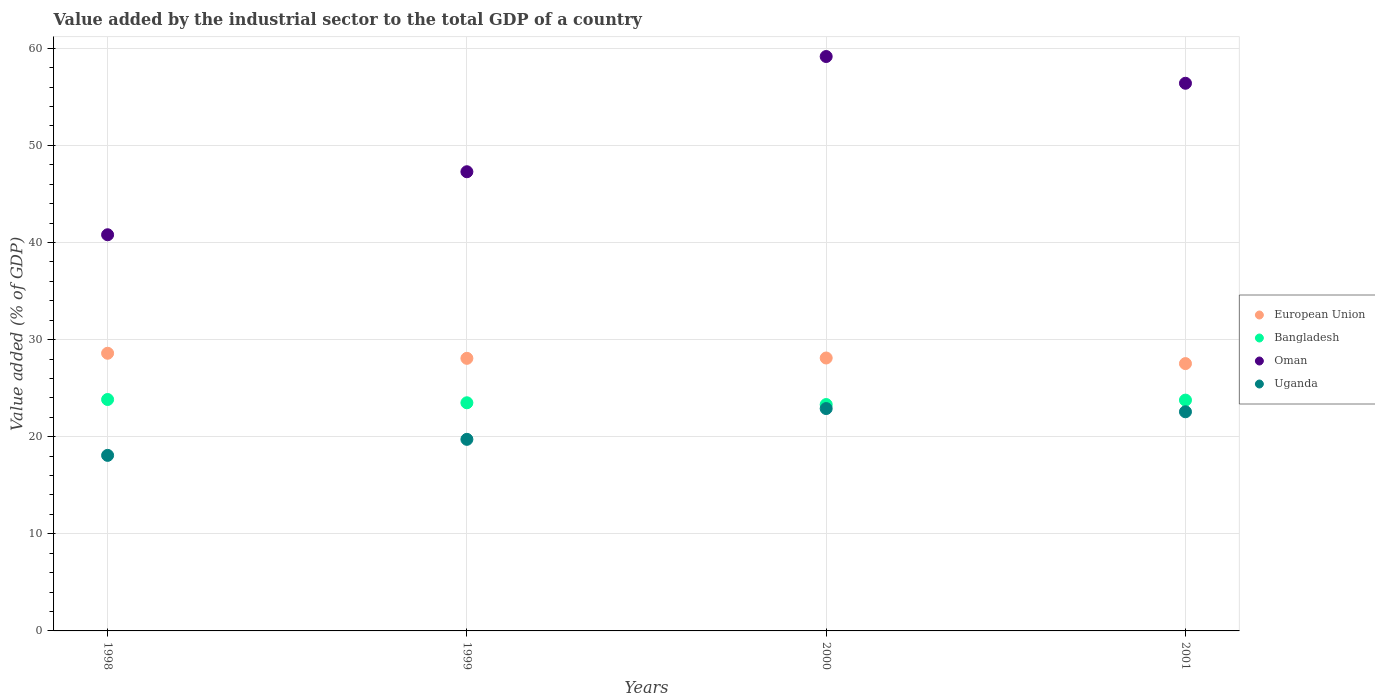How many different coloured dotlines are there?
Your response must be concise. 4. What is the value added by the industrial sector to the total GDP in Uganda in 1998?
Your answer should be compact. 18.08. Across all years, what is the maximum value added by the industrial sector to the total GDP in European Union?
Offer a terse response. 28.6. Across all years, what is the minimum value added by the industrial sector to the total GDP in European Union?
Provide a short and direct response. 27.53. What is the total value added by the industrial sector to the total GDP in European Union in the graph?
Provide a succinct answer. 112.31. What is the difference between the value added by the industrial sector to the total GDP in Uganda in 1998 and that in 2001?
Your answer should be compact. -4.49. What is the difference between the value added by the industrial sector to the total GDP in Bangladesh in 1999 and the value added by the industrial sector to the total GDP in Oman in 2001?
Offer a very short reply. -32.91. What is the average value added by the industrial sector to the total GDP in Bangladesh per year?
Your answer should be compact. 23.6. In the year 1998, what is the difference between the value added by the industrial sector to the total GDP in Bangladesh and value added by the industrial sector to the total GDP in European Union?
Your response must be concise. -4.76. In how many years, is the value added by the industrial sector to the total GDP in Oman greater than 22 %?
Your answer should be compact. 4. What is the ratio of the value added by the industrial sector to the total GDP in European Union in 1998 to that in 2001?
Your response must be concise. 1.04. What is the difference between the highest and the second highest value added by the industrial sector to the total GDP in Uganda?
Provide a succinct answer. 0.33. What is the difference between the highest and the lowest value added by the industrial sector to the total GDP in Oman?
Your answer should be compact. 18.36. In how many years, is the value added by the industrial sector to the total GDP in Uganda greater than the average value added by the industrial sector to the total GDP in Uganda taken over all years?
Keep it short and to the point. 2. Is it the case that in every year, the sum of the value added by the industrial sector to the total GDP in Uganda and value added by the industrial sector to the total GDP in Bangladesh  is greater than the value added by the industrial sector to the total GDP in European Union?
Offer a terse response. Yes. Is the value added by the industrial sector to the total GDP in Oman strictly greater than the value added by the industrial sector to the total GDP in European Union over the years?
Your answer should be compact. Yes. Is the value added by the industrial sector to the total GDP in European Union strictly less than the value added by the industrial sector to the total GDP in Bangladesh over the years?
Give a very brief answer. No. How many dotlines are there?
Offer a terse response. 4. Are the values on the major ticks of Y-axis written in scientific E-notation?
Make the answer very short. No. Does the graph contain any zero values?
Provide a succinct answer. No. What is the title of the graph?
Give a very brief answer. Value added by the industrial sector to the total GDP of a country. What is the label or title of the X-axis?
Give a very brief answer. Years. What is the label or title of the Y-axis?
Your answer should be very brief. Value added (% of GDP). What is the Value added (% of GDP) in European Union in 1998?
Ensure brevity in your answer.  28.6. What is the Value added (% of GDP) of Bangladesh in 1998?
Ensure brevity in your answer.  23.83. What is the Value added (% of GDP) of Oman in 1998?
Offer a very short reply. 40.8. What is the Value added (% of GDP) of Uganda in 1998?
Offer a terse response. 18.08. What is the Value added (% of GDP) in European Union in 1999?
Provide a succinct answer. 28.07. What is the Value added (% of GDP) in Bangladesh in 1999?
Your answer should be very brief. 23.5. What is the Value added (% of GDP) of Oman in 1999?
Keep it short and to the point. 47.29. What is the Value added (% of GDP) of Uganda in 1999?
Your answer should be very brief. 19.73. What is the Value added (% of GDP) in European Union in 2000?
Make the answer very short. 28.11. What is the Value added (% of GDP) of Bangladesh in 2000?
Keep it short and to the point. 23.31. What is the Value added (% of GDP) of Oman in 2000?
Offer a very short reply. 59.16. What is the Value added (% of GDP) in Uganda in 2000?
Keep it short and to the point. 22.9. What is the Value added (% of GDP) in European Union in 2001?
Ensure brevity in your answer.  27.53. What is the Value added (% of GDP) of Bangladesh in 2001?
Provide a succinct answer. 23.77. What is the Value added (% of GDP) in Oman in 2001?
Keep it short and to the point. 56.4. What is the Value added (% of GDP) of Uganda in 2001?
Make the answer very short. 22.57. Across all years, what is the maximum Value added (% of GDP) of European Union?
Provide a succinct answer. 28.6. Across all years, what is the maximum Value added (% of GDP) in Bangladesh?
Make the answer very short. 23.83. Across all years, what is the maximum Value added (% of GDP) of Oman?
Keep it short and to the point. 59.16. Across all years, what is the maximum Value added (% of GDP) in Uganda?
Make the answer very short. 22.9. Across all years, what is the minimum Value added (% of GDP) of European Union?
Your answer should be compact. 27.53. Across all years, what is the minimum Value added (% of GDP) of Bangladesh?
Make the answer very short. 23.31. Across all years, what is the minimum Value added (% of GDP) in Oman?
Give a very brief answer. 40.8. Across all years, what is the minimum Value added (% of GDP) in Uganda?
Offer a terse response. 18.08. What is the total Value added (% of GDP) of European Union in the graph?
Give a very brief answer. 112.31. What is the total Value added (% of GDP) in Bangladesh in the graph?
Keep it short and to the point. 94.41. What is the total Value added (% of GDP) of Oman in the graph?
Keep it short and to the point. 203.64. What is the total Value added (% of GDP) in Uganda in the graph?
Offer a terse response. 83.28. What is the difference between the Value added (% of GDP) in European Union in 1998 and that in 1999?
Keep it short and to the point. 0.52. What is the difference between the Value added (% of GDP) of Bangladesh in 1998 and that in 1999?
Provide a short and direct response. 0.34. What is the difference between the Value added (% of GDP) in Oman in 1998 and that in 1999?
Make the answer very short. -6.49. What is the difference between the Value added (% of GDP) of Uganda in 1998 and that in 1999?
Keep it short and to the point. -1.65. What is the difference between the Value added (% of GDP) of European Union in 1998 and that in 2000?
Offer a terse response. 0.49. What is the difference between the Value added (% of GDP) of Bangladesh in 1998 and that in 2000?
Give a very brief answer. 0.52. What is the difference between the Value added (% of GDP) of Oman in 1998 and that in 2000?
Your response must be concise. -18.36. What is the difference between the Value added (% of GDP) in Uganda in 1998 and that in 2000?
Offer a very short reply. -4.82. What is the difference between the Value added (% of GDP) in European Union in 1998 and that in 2001?
Your answer should be very brief. 1.06. What is the difference between the Value added (% of GDP) of Bangladesh in 1998 and that in 2001?
Your answer should be compact. 0.06. What is the difference between the Value added (% of GDP) of Oman in 1998 and that in 2001?
Your response must be concise. -15.6. What is the difference between the Value added (% of GDP) of Uganda in 1998 and that in 2001?
Your answer should be compact. -4.49. What is the difference between the Value added (% of GDP) of European Union in 1999 and that in 2000?
Offer a terse response. -0.03. What is the difference between the Value added (% of GDP) in Bangladesh in 1999 and that in 2000?
Make the answer very short. 0.18. What is the difference between the Value added (% of GDP) in Oman in 1999 and that in 2000?
Offer a terse response. -11.87. What is the difference between the Value added (% of GDP) of Uganda in 1999 and that in 2000?
Your answer should be compact. -3.17. What is the difference between the Value added (% of GDP) in European Union in 1999 and that in 2001?
Ensure brevity in your answer.  0.54. What is the difference between the Value added (% of GDP) in Bangladesh in 1999 and that in 2001?
Keep it short and to the point. -0.27. What is the difference between the Value added (% of GDP) of Oman in 1999 and that in 2001?
Your response must be concise. -9.11. What is the difference between the Value added (% of GDP) of Uganda in 1999 and that in 2001?
Your answer should be compact. -2.84. What is the difference between the Value added (% of GDP) in European Union in 2000 and that in 2001?
Keep it short and to the point. 0.58. What is the difference between the Value added (% of GDP) in Bangladesh in 2000 and that in 2001?
Ensure brevity in your answer.  -0.46. What is the difference between the Value added (% of GDP) of Oman in 2000 and that in 2001?
Offer a terse response. 2.75. What is the difference between the Value added (% of GDP) of Uganda in 2000 and that in 2001?
Give a very brief answer. 0.33. What is the difference between the Value added (% of GDP) in European Union in 1998 and the Value added (% of GDP) in Oman in 1999?
Provide a succinct answer. -18.69. What is the difference between the Value added (% of GDP) of European Union in 1998 and the Value added (% of GDP) of Uganda in 1999?
Provide a short and direct response. 8.87. What is the difference between the Value added (% of GDP) of Bangladesh in 1998 and the Value added (% of GDP) of Oman in 1999?
Ensure brevity in your answer.  -23.46. What is the difference between the Value added (% of GDP) of Bangladesh in 1998 and the Value added (% of GDP) of Uganda in 1999?
Keep it short and to the point. 4.1. What is the difference between the Value added (% of GDP) in Oman in 1998 and the Value added (% of GDP) in Uganda in 1999?
Ensure brevity in your answer.  21.07. What is the difference between the Value added (% of GDP) of European Union in 1998 and the Value added (% of GDP) of Bangladesh in 2000?
Your answer should be compact. 5.28. What is the difference between the Value added (% of GDP) of European Union in 1998 and the Value added (% of GDP) of Oman in 2000?
Your response must be concise. -30.56. What is the difference between the Value added (% of GDP) in European Union in 1998 and the Value added (% of GDP) in Uganda in 2000?
Your response must be concise. 5.7. What is the difference between the Value added (% of GDP) in Bangladesh in 1998 and the Value added (% of GDP) in Oman in 2000?
Your response must be concise. -35.32. What is the difference between the Value added (% of GDP) of Bangladesh in 1998 and the Value added (% of GDP) of Uganda in 2000?
Give a very brief answer. 0.93. What is the difference between the Value added (% of GDP) of Oman in 1998 and the Value added (% of GDP) of Uganda in 2000?
Offer a very short reply. 17.9. What is the difference between the Value added (% of GDP) in European Union in 1998 and the Value added (% of GDP) in Bangladesh in 2001?
Give a very brief answer. 4.83. What is the difference between the Value added (% of GDP) in European Union in 1998 and the Value added (% of GDP) in Oman in 2001?
Your answer should be very brief. -27.81. What is the difference between the Value added (% of GDP) of European Union in 1998 and the Value added (% of GDP) of Uganda in 2001?
Make the answer very short. 6.03. What is the difference between the Value added (% of GDP) of Bangladesh in 1998 and the Value added (% of GDP) of Oman in 2001?
Make the answer very short. -32.57. What is the difference between the Value added (% of GDP) of Bangladesh in 1998 and the Value added (% of GDP) of Uganda in 2001?
Provide a short and direct response. 1.26. What is the difference between the Value added (% of GDP) in Oman in 1998 and the Value added (% of GDP) in Uganda in 2001?
Make the answer very short. 18.23. What is the difference between the Value added (% of GDP) of European Union in 1999 and the Value added (% of GDP) of Bangladesh in 2000?
Offer a very short reply. 4.76. What is the difference between the Value added (% of GDP) in European Union in 1999 and the Value added (% of GDP) in Oman in 2000?
Keep it short and to the point. -31.08. What is the difference between the Value added (% of GDP) of European Union in 1999 and the Value added (% of GDP) of Uganda in 2000?
Your answer should be compact. 5.17. What is the difference between the Value added (% of GDP) in Bangladesh in 1999 and the Value added (% of GDP) in Oman in 2000?
Make the answer very short. -35.66. What is the difference between the Value added (% of GDP) of Bangladesh in 1999 and the Value added (% of GDP) of Uganda in 2000?
Your response must be concise. 0.6. What is the difference between the Value added (% of GDP) in Oman in 1999 and the Value added (% of GDP) in Uganda in 2000?
Your answer should be very brief. 24.39. What is the difference between the Value added (% of GDP) of European Union in 1999 and the Value added (% of GDP) of Bangladesh in 2001?
Your response must be concise. 4.3. What is the difference between the Value added (% of GDP) in European Union in 1999 and the Value added (% of GDP) in Oman in 2001?
Provide a short and direct response. -28.33. What is the difference between the Value added (% of GDP) of European Union in 1999 and the Value added (% of GDP) of Uganda in 2001?
Your answer should be compact. 5.5. What is the difference between the Value added (% of GDP) of Bangladesh in 1999 and the Value added (% of GDP) of Oman in 2001?
Provide a succinct answer. -32.91. What is the difference between the Value added (% of GDP) of Bangladesh in 1999 and the Value added (% of GDP) of Uganda in 2001?
Give a very brief answer. 0.93. What is the difference between the Value added (% of GDP) of Oman in 1999 and the Value added (% of GDP) of Uganda in 2001?
Your answer should be compact. 24.72. What is the difference between the Value added (% of GDP) of European Union in 2000 and the Value added (% of GDP) of Bangladesh in 2001?
Offer a very short reply. 4.34. What is the difference between the Value added (% of GDP) of European Union in 2000 and the Value added (% of GDP) of Oman in 2001?
Provide a succinct answer. -28.29. What is the difference between the Value added (% of GDP) of European Union in 2000 and the Value added (% of GDP) of Uganda in 2001?
Ensure brevity in your answer.  5.54. What is the difference between the Value added (% of GDP) of Bangladesh in 2000 and the Value added (% of GDP) of Oman in 2001?
Your response must be concise. -33.09. What is the difference between the Value added (% of GDP) in Bangladesh in 2000 and the Value added (% of GDP) in Uganda in 2001?
Your answer should be compact. 0.75. What is the difference between the Value added (% of GDP) in Oman in 2000 and the Value added (% of GDP) in Uganda in 2001?
Provide a short and direct response. 36.59. What is the average Value added (% of GDP) of European Union per year?
Provide a succinct answer. 28.08. What is the average Value added (% of GDP) in Bangladesh per year?
Your response must be concise. 23.6. What is the average Value added (% of GDP) of Oman per year?
Provide a succinct answer. 50.91. What is the average Value added (% of GDP) in Uganda per year?
Ensure brevity in your answer.  20.82. In the year 1998, what is the difference between the Value added (% of GDP) in European Union and Value added (% of GDP) in Bangladesh?
Give a very brief answer. 4.76. In the year 1998, what is the difference between the Value added (% of GDP) in European Union and Value added (% of GDP) in Oman?
Provide a succinct answer. -12.2. In the year 1998, what is the difference between the Value added (% of GDP) in European Union and Value added (% of GDP) in Uganda?
Make the answer very short. 10.52. In the year 1998, what is the difference between the Value added (% of GDP) of Bangladesh and Value added (% of GDP) of Oman?
Offer a very short reply. -16.97. In the year 1998, what is the difference between the Value added (% of GDP) in Bangladesh and Value added (% of GDP) in Uganda?
Your answer should be very brief. 5.75. In the year 1998, what is the difference between the Value added (% of GDP) in Oman and Value added (% of GDP) in Uganda?
Your answer should be compact. 22.72. In the year 1999, what is the difference between the Value added (% of GDP) of European Union and Value added (% of GDP) of Bangladesh?
Your response must be concise. 4.58. In the year 1999, what is the difference between the Value added (% of GDP) in European Union and Value added (% of GDP) in Oman?
Make the answer very short. -19.22. In the year 1999, what is the difference between the Value added (% of GDP) in European Union and Value added (% of GDP) in Uganda?
Make the answer very short. 8.34. In the year 1999, what is the difference between the Value added (% of GDP) in Bangladesh and Value added (% of GDP) in Oman?
Ensure brevity in your answer.  -23.79. In the year 1999, what is the difference between the Value added (% of GDP) in Bangladesh and Value added (% of GDP) in Uganda?
Your response must be concise. 3.77. In the year 1999, what is the difference between the Value added (% of GDP) in Oman and Value added (% of GDP) in Uganda?
Ensure brevity in your answer.  27.56. In the year 2000, what is the difference between the Value added (% of GDP) of European Union and Value added (% of GDP) of Bangladesh?
Your answer should be compact. 4.79. In the year 2000, what is the difference between the Value added (% of GDP) of European Union and Value added (% of GDP) of Oman?
Your answer should be compact. -31.05. In the year 2000, what is the difference between the Value added (% of GDP) in European Union and Value added (% of GDP) in Uganda?
Your answer should be compact. 5.21. In the year 2000, what is the difference between the Value added (% of GDP) in Bangladesh and Value added (% of GDP) in Oman?
Provide a short and direct response. -35.84. In the year 2000, what is the difference between the Value added (% of GDP) in Bangladesh and Value added (% of GDP) in Uganda?
Give a very brief answer. 0.41. In the year 2000, what is the difference between the Value added (% of GDP) of Oman and Value added (% of GDP) of Uganda?
Provide a short and direct response. 36.26. In the year 2001, what is the difference between the Value added (% of GDP) of European Union and Value added (% of GDP) of Bangladesh?
Provide a short and direct response. 3.76. In the year 2001, what is the difference between the Value added (% of GDP) of European Union and Value added (% of GDP) of Oman?
Provide a short and direct response. -28.87. In the year 2001, what is the difference between the Value added (% of GDP) of European Union and Value added (% of GDP) of Uganda?
Offer a very short reply. 4.96. In the year 2001, what is the difference between the Value added (% of GDP) in Bangladesh and Value added (% of GDP) in Oman?
Your response must be concise. -32.63. In the year 2001, what is the difference between the Value added (% of GDP) of Bangladesh and Value added (% of GDP) of Uganda?
Your answer should be very brief. 1.2. In the year 2001, what is the difference between the Value added (% of GDP) in Oman and Value added (% of GDP) in Uganda?
Your response must be concise. 33.83. What is the ratio of the Value added (% of GDP) of European Union in 1998 to that in 1999?
Your response must be concise. 1.02. What is the ratio of the Value added (% of GDP) of Bangladesh in 1998 to that in 1999?
Ensure brevity in your answer.  1.01. What is the ratio of the Value added (% of GDP) in Oman in 1998 to that in 1999?
Your answer should be very brief. 0.86. What is the ratio of the Value added (% of GDP) of Uganda in 1998 to that in 1999?
Your answer should be very brief. 0.92. What is the ratio of the Value added (% of GDP) of European Union in 1998 to that in 2000?
Your answer should be very brief. 1.02. What is the ratio of the Value added (% of GDP) of Bangladesh in 1998 to that in 2000?
Your response must be concise. 1.02. What is the ratio of the Value added (% of GDP) in Oman in 1998 to that in 2000?
Make the answer very short. 0.69. What is the ratio of the Value added (% of GDP) of Uganda in 1998 to that in 2000?
Offer a terse response. 0.79. What is the ratio of the Value added (% of GDP) of European Union in 1998 to that in 2001?
Offer a terse response. 1.04. What is the ratio of the Value added (% of GDP) of Oman in 1998 to that in 2001?
Your answer should be very brief. 0.72. What is the ratio of the Value added (% of GDP) in Uganda in 1998 to that in 2001?
Offer a terse response. 0.8. What is the ratio of the Value added (% of GDP) in Bangladesh in 1999 to that in 2000?
Provide a succinct answer. 1.01. What is the ratio of the Value added (% of GDP) in Oman in 1999 to that in 2000?
Your answer should be very brief. 0.8. What is the ratio of the Value added (% of GDP) of Uganda in 1999 to that in 2000?
Give a very brief answer. 0.86. What is the ratio of the Value added (% of GDP) of European Union in 1999 to that in 2001?
Offer a very short reply. 1.02. What is the ratio of the Value added (% of GDP) of Oman in 1999 to that in 2001?
Your answer should be very brief. 0.84. What is the ratio of the Value added (% of GDP) of Uganda in 1999 to that in 2001?
Keep it short and to the point. 0.87. What is the ratio of the Value added (% of GDP) in European Union in 2000 to that in 2001?
Your answer should be compact. 1.02. What is the ratio of the Value added (% of GDP) in Bangladesh in 2000 to that in 2001?
Give a very brief answer. 0.98. What is the ratio of the Value added (% of GDP) in Oman in 2000 to that in 2001?
Your response must be concise. 1.05. What is the ratio of the Value added (% of GDP) of Uganda in 2000 to that in 2001?
Provide a short and direct response. 1.01. What is the difference between the highest and the second highest Value added (% of GDP) in European Union?
Your answer should be compact. 0.49. What is the difference between the highest and the second highest Value added (% of GDP) of Bangladesh?
Provide a short and direct response. 0.06. What is the difference between the highest and the second highest Value added (% of GDP) in Oman?
Your answer should be very brief. 2.75. What is the difference between the highest and the second highest Value added (% of GDP) in Uganda?
Provide a succinct answer. 0.33. What is the difference between the highest and the lowest Value added (% of GDP) in European Union?
Keep it short and to the point. 1.06. What is the difference between the highest and the lowest Value added (% of GDP) in Bangladesh?
Keep it short and to the point. 0.52. What is the difference between the highest and the lowest Value added (% of GDP) of Oman?
Ensure brevity in your answer.  18.36. What is the difference between the highest and the lowest Value added (% of GDP) in Uganda?
Keep it short and to the point. 4.82. 